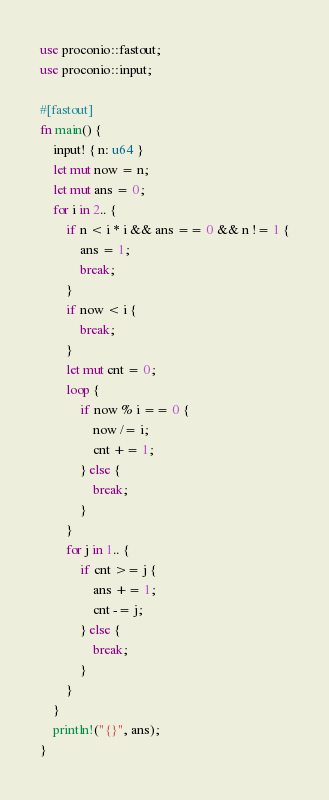<code> <loc_0><loc_0><loc_500><loc_500><_Rust_>use proconio::fastout;
use proconio::input;

#[fastout]
fn main() {
    input! { n: u64 }
    let mut now = n;
    let mut ans = 0;
    for i in 2.. {
        if n < i * i && ans == 0 && n != 1 {
            ans = 1;
            break;
        }
        if now < i {
            break;
        }
        let mut cnt = 0;
        loop {
            if now % i == 0 {
                now /= i;
                cnt += 1;
            } else {
                break;
            }
        }
        for j in 1.. {
            if cnt >= j {
                ans += 1;
                cnt -= j;
            } else {
                break;
            }
        }
    }
    println!("{}", ans);
}
</code> 